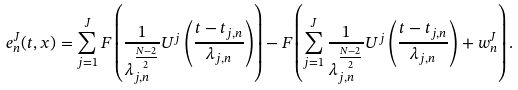Convert formula to latex. <formula><loc_0><loc_0><loc_500><loc_500>e _ { n } ^ { J } ( t , x ) = \sum _ { j = 1 } ^ { J } F \left ( \frac { 1 } { \lambda _ { j , n } ^ { \frac { N - 2 } { 2 } } } U ^ { j } \left ( \frac { t - t _ { j , n } } { \lambda _ { j , n } } \right ) \right ) - F \left ( \sum _ { j = 1 } ^ { J } \frac { 1 } { \lambda _ { j , n } ^ { \frac { N - 2 } { 2 } } } U ^ { j } \left ( \frac { t - t _ { j , n } } { \lambda _ { j , n } } \right ) + w ^ { J } _ { n } \right ) .</formula> 